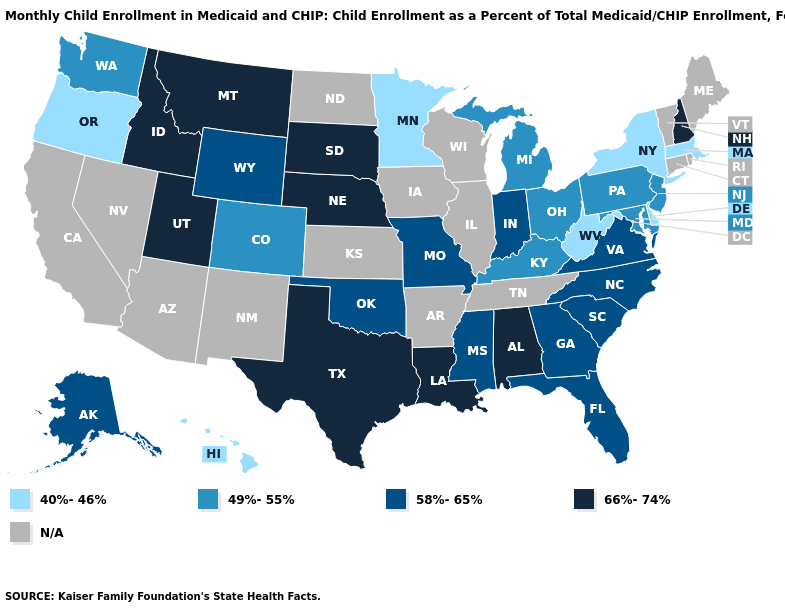What is the value of Tennessee?
Short answer required. N/A. Name the states that have a value in the range 40%-46%?
Concise answer only. Delaware, Hawaii, Massachusetts, Minnesota, New York, Oregon, West Virginia. Name the states that have a value in the range N/A?
Concise answer only. Arizona, Arkansas, California, Connecticut, Illinois, Iowa, Kansas, Maine, Nevada, New Mexico, North Dakota, Rhode Island, Tennessee, Vermont, Wisconsin. What is the value of Alaska?
Short answer required. 58%-65%. Name the states that have a value in the range 58%-65%?
Answer briefly. Alaska, Florida, Georgia, Indiana, Mississippi, Missouri, North Carolina, Oklahoma, South Carolina, Virginia, Wyoming. Name the states that have a value in the range 66%-74%?
Short answer required. Alabama, Idaho, Louisiana, Montana, Nebraska, New Hampshire, South Dakota, Texas, Utah. What is the highest value in states that border Georgia?
Quick response, please. 66%-74%. What is the value of Louisiana?
Be succinct. 66%-74%. What is the value of New York?
Quick response, please. 40%-46%. What is the lowest value in the USA?
Answer briefly. 40%-46%. What is the value of Alabama?
Concise answer only. 66%-74%. What is the value of Wyoming?
Write a very short answer. 58%-65%. 